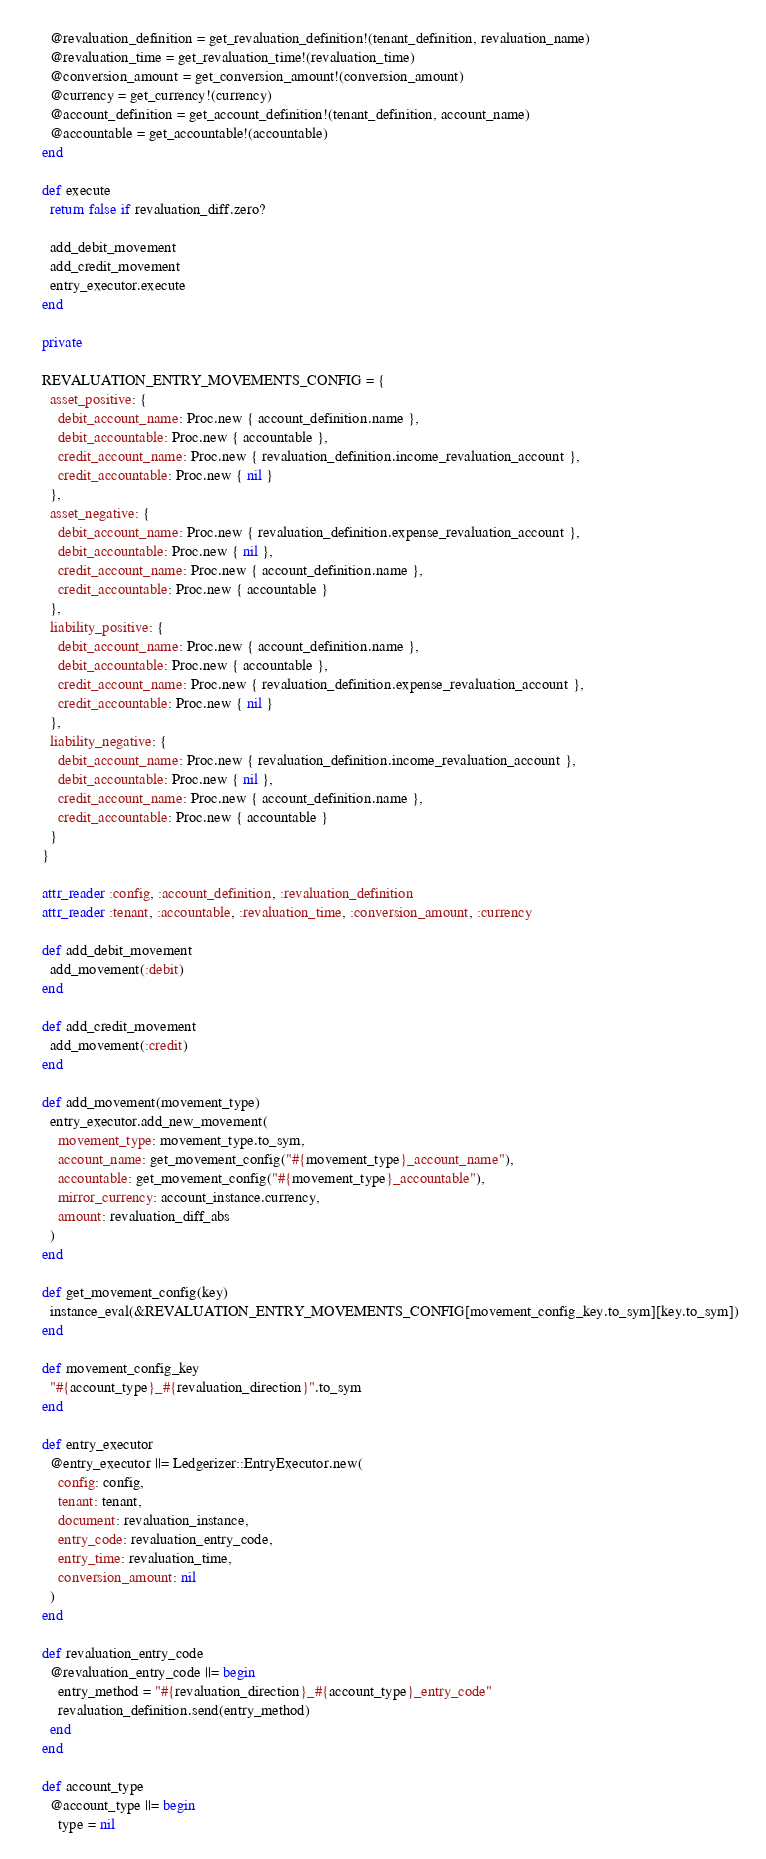<code> <loc_0><loc_0><loc_500><loc_500><_Ruby_>      @revaluation_definition = get_revaluation_definition!(tenant_definition, revaluation_name)
      @revaluation_time = get_revaluation_time!(revaluation_time)
      @conversion_amount = get_conversion_amount!(conversion_amount)
      @currency = get_currency!(currency)
      @account_definition = get_account_definition!(tenant_definition, account_name)
      @accountable = get_accountable!(accountable)
    end

    def execute
      return false if revaluation_diff.zero?

      add_debit_movement
      add_credit_movement
      entry_executor.execute
    end

    private

    REVALUATION_ENTRY_MOVEMENTS_CONFIG = {
      asset_positive: {
        debit_account_name: Proc.new { account_definition.name },
        debit_accountable: Proc.new { accountable },
        credit_account_name: Proc.new { revaluation_definition.income_revaluation_account },
        credit_accountable: Proc.new { nil }
      },
      asset_negative: {
        debit_account_name: Proc.new { revaluation_definition.expense_revaluation_account },
        debit_accountable: Proc.new { nil },
        credit_account_name: Proc.new { account_definition.name },
        credit_accountable: Proc.new { accountable }
      },
      liability_positive: {
        debit_account_name: Proc.new { account_definition.name },
        debit_accountable: Proc.new { accountable },
        credit_account_name: Proc.new { revaluation_definition.expense_revaluation_account },
        credit_accountable: Proc.new { nil }
      },
      liability_negative: {
        debit_account_name: Proc.new { revaluation_definition.income_revaluation_account },
        debit_accountable: Proc.new { nil },
        credit_account_name: Proc.new { account_definition.name },
        credit_accountable: Proc.new { accountable }
      }
    }

    attr_reader :config, :account_definition, :revaluation_definition
    attr_reader :tenant, :accountable, :revaluation_time, :conversion_amount, :currency

    def add_debit_movement
      add_movement(:debit)
    end

    def add_credit_movement
      add_movement(:credit)
    end

    def add_movement(movement_type)
      entry_executor.add_new_movement(
        movement_type: movement_type.to_sym,
        account_name: get_movement_config("#{movement_type}_account_name"),
        accountable: get_movement_config("#{movement_type}_accountable"),
        mirror_currency: account_instance.currency,
        amount: revaluation_diff_abs
      )
    end

    def get_movement_config(key)
      instance_eval(&REVALUATION_ENTRY_MOVEMENTS_CONFIG[movement_config_key.to_sym][key.to_sym])
    end

    def movement_config_key
      "#{account_type}_#{revaluation_direction}".to_sym
    end

    def entry_executor
      @entry_executor ||= Ledgerizer::EntryExecutor.new(
        config: config,
        tenant: tenant,
        document: revaluation_instance,
        entry_code: revaluation_entry_code,
        entry_time: revaluation_time,
        conversion_amount: nil
      )
    end

    def revaluation_entry_code
      @revaluation_entry_code ||= begin
        entry_method = "#{revaluation_direction}_#{account_type}_entry_code"
        revaluation_definition.send(entry_method)
      end
    end

    def account_type
      @account_type ||= begin
        type = nil
</code> 